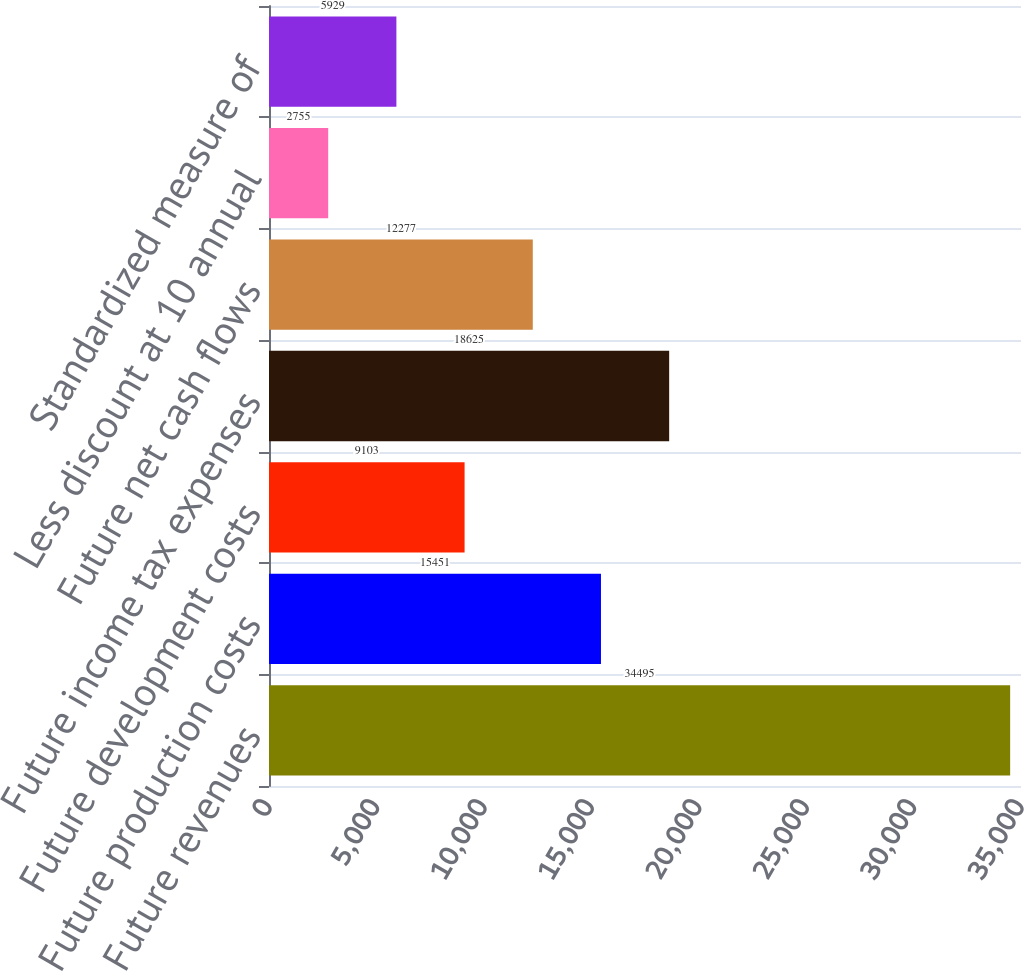<chart> <loc_0><loc_0><loc_500><loc_500><bar_chart><fcel>Future revenues<fcel>Future production costs<fcel>Future development costs<fcel>Future income tax expenses<fcel>Future net cash flows<fcel>Less discount at 10 annual<fcel>Standardized measure of<nl><fcel>34495<fcel>15451<fcel>9103<fcel>18625<fcel>12277<fcel>2755<fcel>5929<nl></chart> 